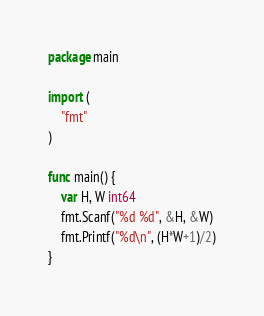Convert code to text. <code><loc_0><loc_0><loc_500><loc_500><_Go_>package main

import (
	"fmt"
)

func main() {
	var H, W int64
	fmt.Scanf("%d %d", &H, &W)
	fmt.Printf("%d\n", (H*W+1)/2)
}
</code> 